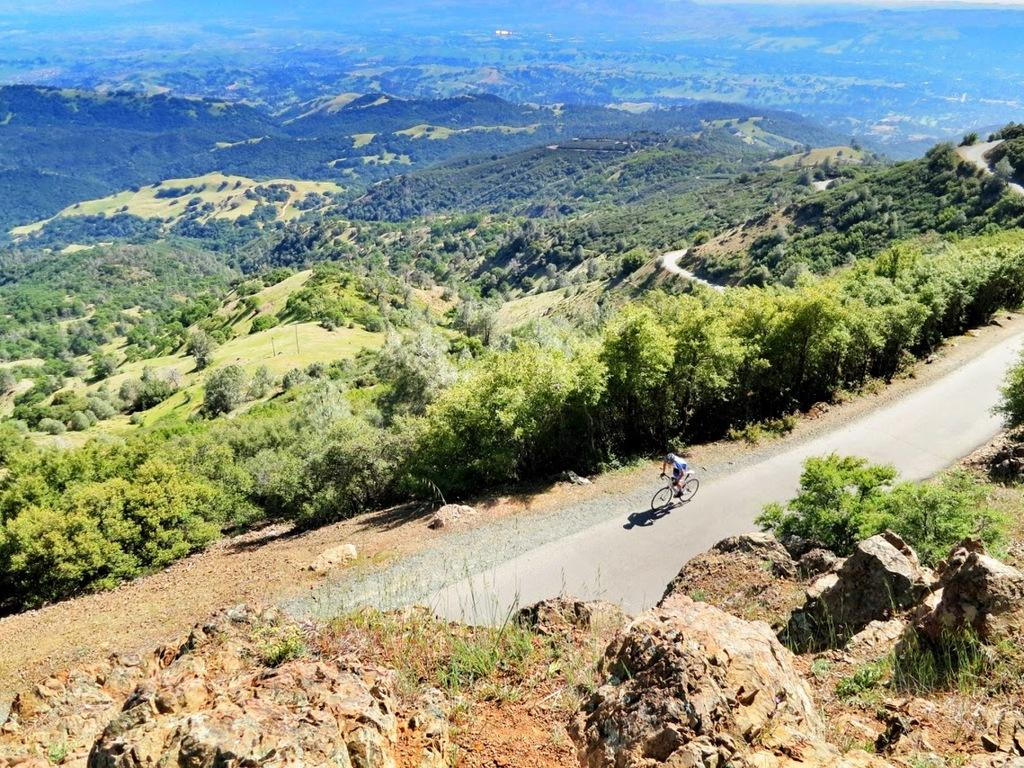What is the person in the image doing? There is a person bicycling in the image. Where is the person bicycling? The person is on the road. What can be seen in the background of the image? There are trees, hills, and grass visible in the image. Are there any other natural elements present in the image? Yes, there are rocks in the image. What type of wool can be seen on the bushes in the image? There are no bushes or wool present in the image. How do the waves affect the person bicycling in the image? There are no waves present in the image; it is a person bicycling on a road with hills and trees in the background. 